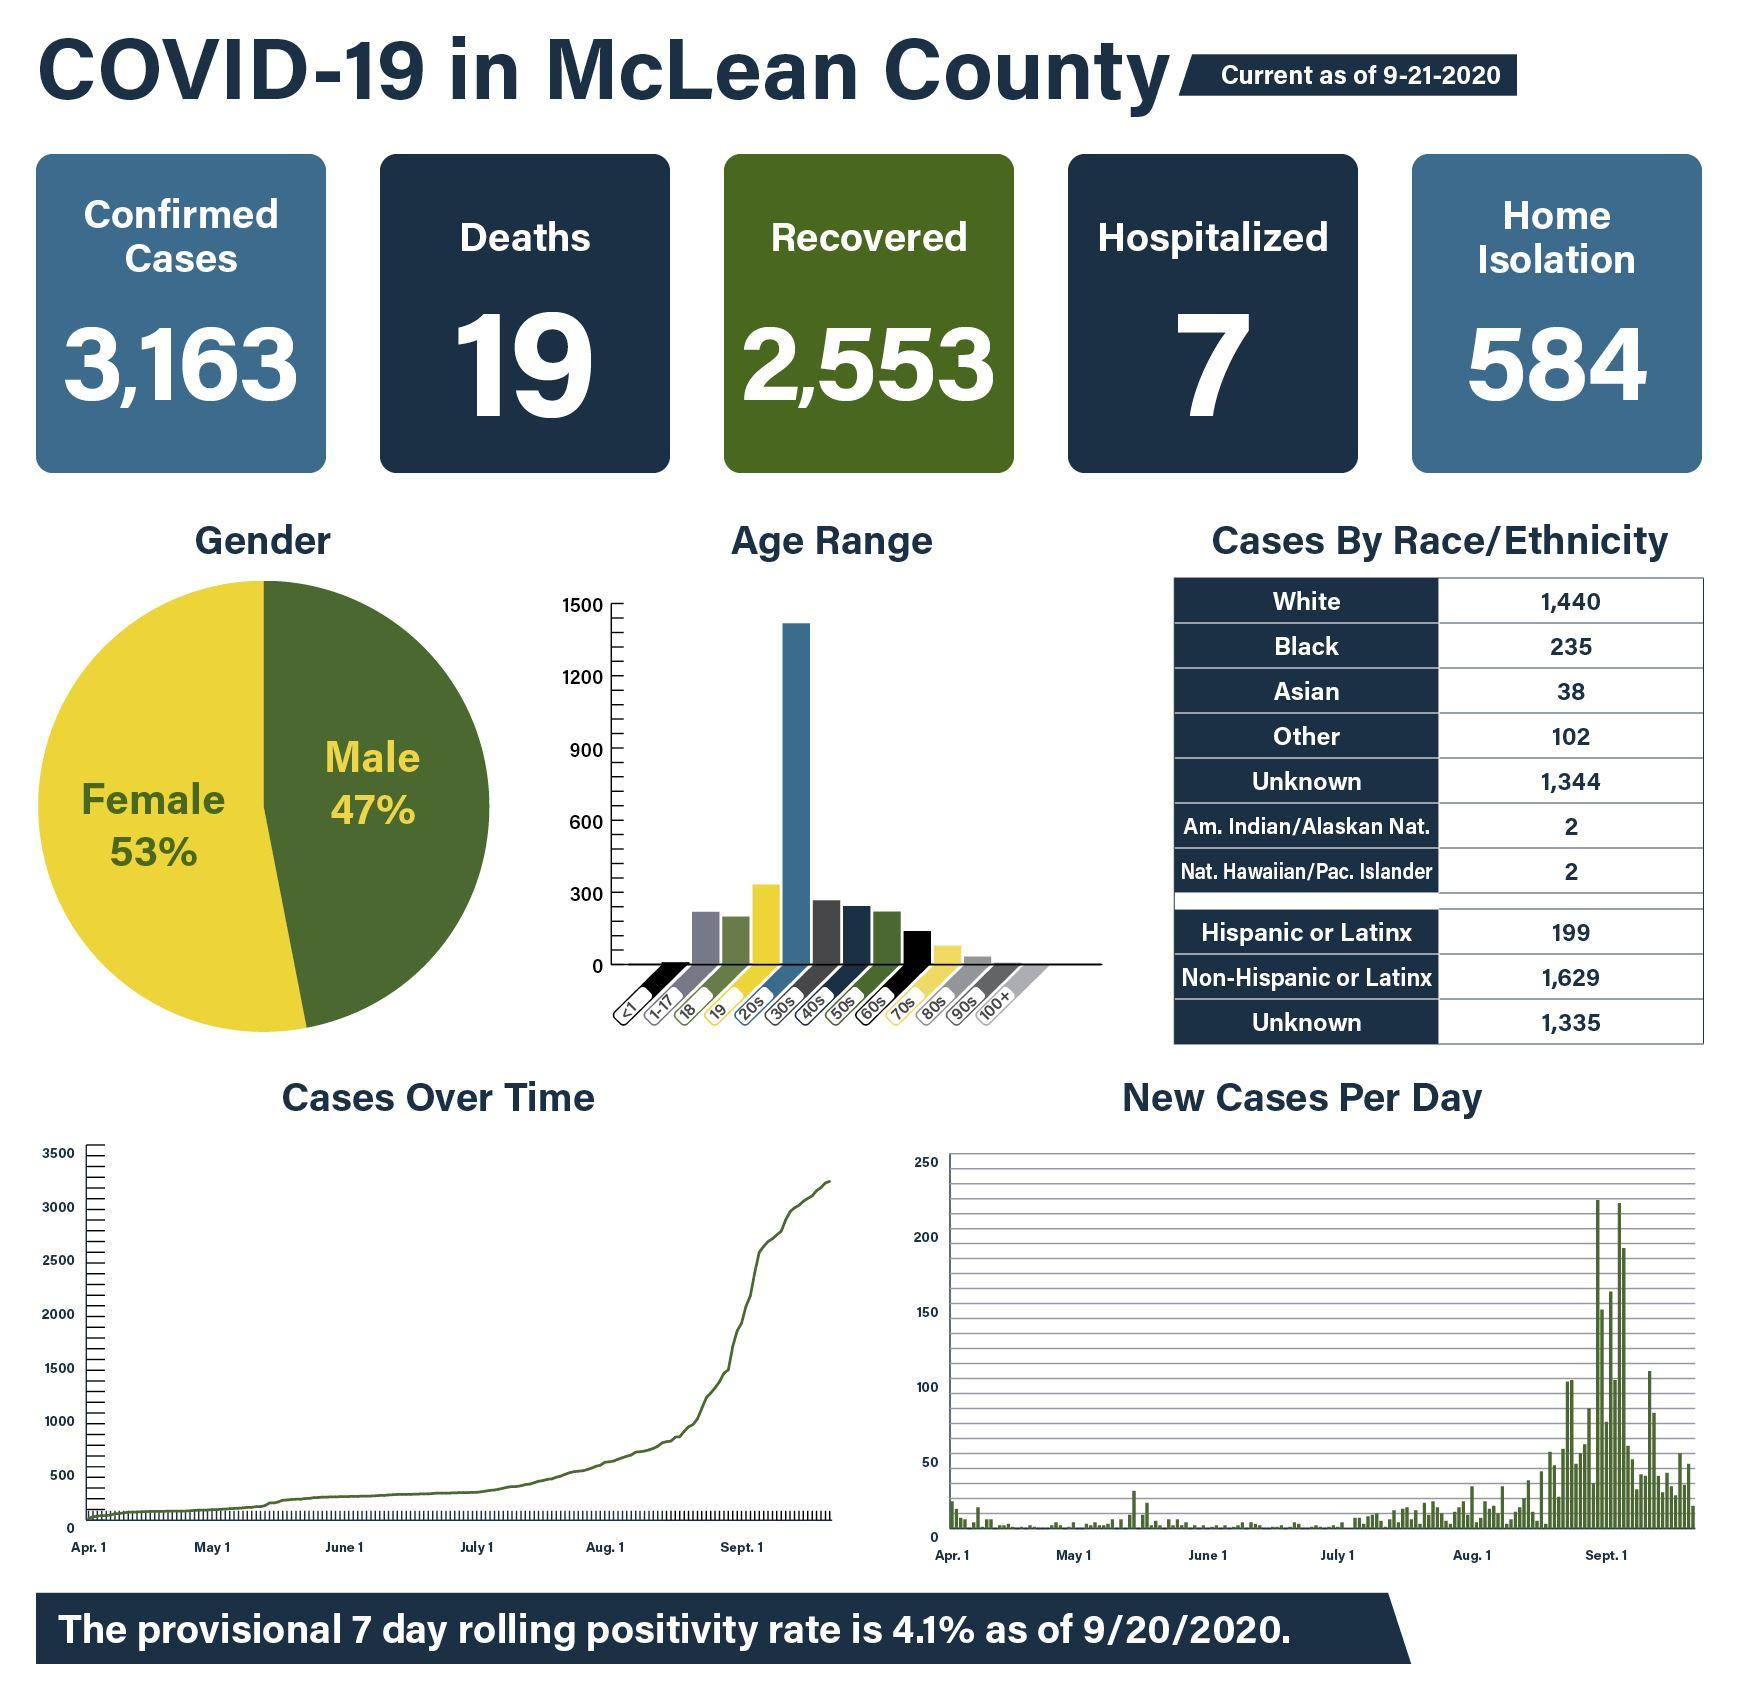Mention a couple of crucial points in this snapshot. There were 2,553 cases that were successfully recovered. Out of the age groups, there are two that have a number of cases that are equal to or greater than 300. Out of all age groups, those in the 19s and 20s have the highest number of cases with over 300. The number of cases in races where the number of races is equal to 2 is 2. The question asks about the gender distribution of two groups and aims to determine which one has a higher percentage of female members. 